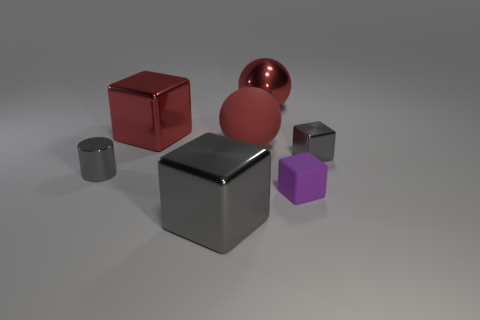What is the color of the big sphere that is the same material as the small purple cube?
Provide a short and direct response. Red. Is the small matte block the same color as the big matte sphere?
Keep it short and to the point. No. There is a rubber object that is the same size as the gray metal cylinder; what shape is it?
Provide a short and direct response. Cube. The purple thing has what size?
Offer a very short reply. Small. There is a block on the right side of the purple rubber block; is its size the same as the red metallic object on the right side of the large red block?
Keep it short and to the point. No. What is the color of the big sphere that is behind the big block behind the metal cylinder?
Make the answer very short. Red. What material is the other red ball that is the same size as the shiny sphere?
Make the answer very short. Rubber. How many matte objects are large gray blocks or small spheres?
Offer a terse response. 0. The thing that is both behind the large matte sphere and on the right side of the matte sphere is what color?
Keep it short and to the point. Red. There is a shiny cylinder; what number of small metal objects are behind it?
Offer a terse response. 1. 